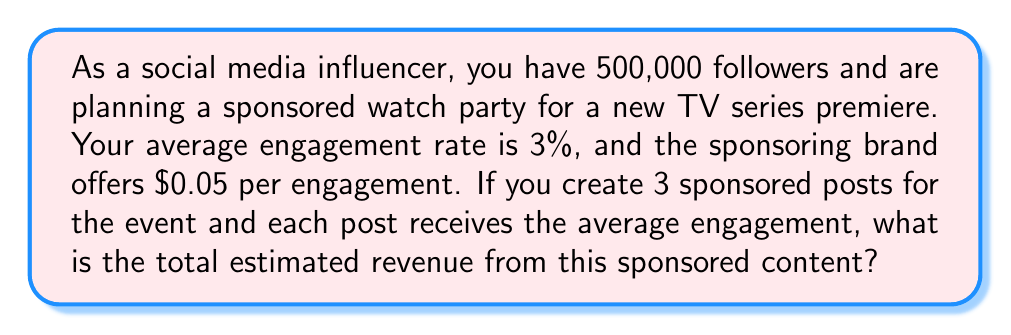Solve this math problem. To solve this problem, we'll follow these steps:

1. Calculate the number of engagements per post:
   - Number of followers: 500,000
   - Engagement rate: 3% = 0.03
   - Engagements per post = $500,000 \times 0.03 = 15,000$

2. Calculate the revenue per post:
   - Revenue per engagement: $0.05
   - Revenue per post = $15,000 \times $0.05 = $750$

3. Calculate the total revenue for all 3 posts:
   - Number of posts: 3
   - Total revenue = $750 \times 3 = $2,250$

Let's express this mathematically:

$$\text{Total Revenue} = \text{Followers} \times \text{Engagement Rate} \times \text{Revenue per Engagement} \times \text{Number of Posts}$$

Plugging in the values:

$$\text{Total Revenue} = 500,000 \times 0.03 \times $0.05 \times 3 = $2,250$$

Therefore, the estimated total revenue from the sponsored content for the watch party is $2,250.
Answer: $2,250 